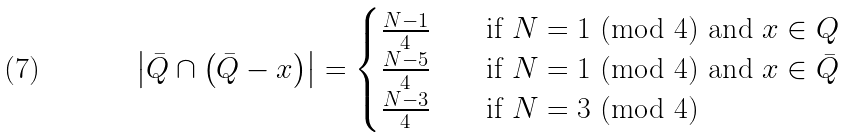<formula> <loc_0><loc_0><loc_500><loc_500>\left | \bar { Q } \cap \left ( \bar { Q } - x \right ) \right | = \begin{cases} \frac { N - 1 } { 4 } \quad & \text {if $N=1$ (mod $4$) and $x\in Q$ } \\ \frac { N - 5 } { 4 } \quad & \text {if $N=1$ (mod $4$) and $x\in \bar{Q}$} \\ \frac { N - 3 } { 4 } \quad & \text {if $N=3$ (mod $4$)} \end{cases}</formula> 